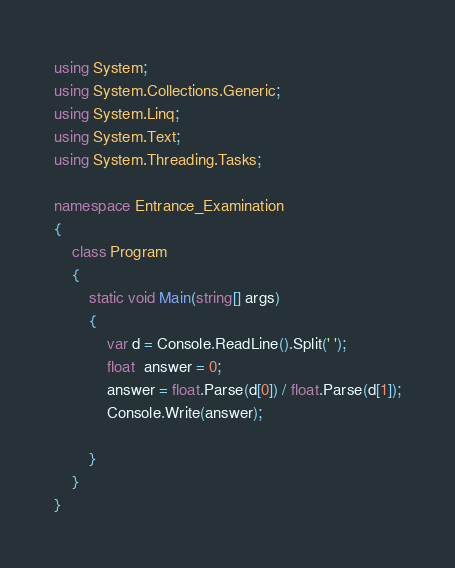Convert code to text. <code><loc_0><loc_0><loc_500><loc_500><_C#_>using System;
using System.Collections.Generic;
using System.Linq;
using System.Text;
using System.Threading.Tasks;

namespace Entrance_Examination
{
    class Program
    {
        static void Main(string[] args)
        {
            var d = Console.ReadLine().Split(' ');
            float  answer = 0;
            answer = float.Parse(d[0]) / float.Parse(d[1]);
            Console.Write(answer);

        }
    }
}
</code> 